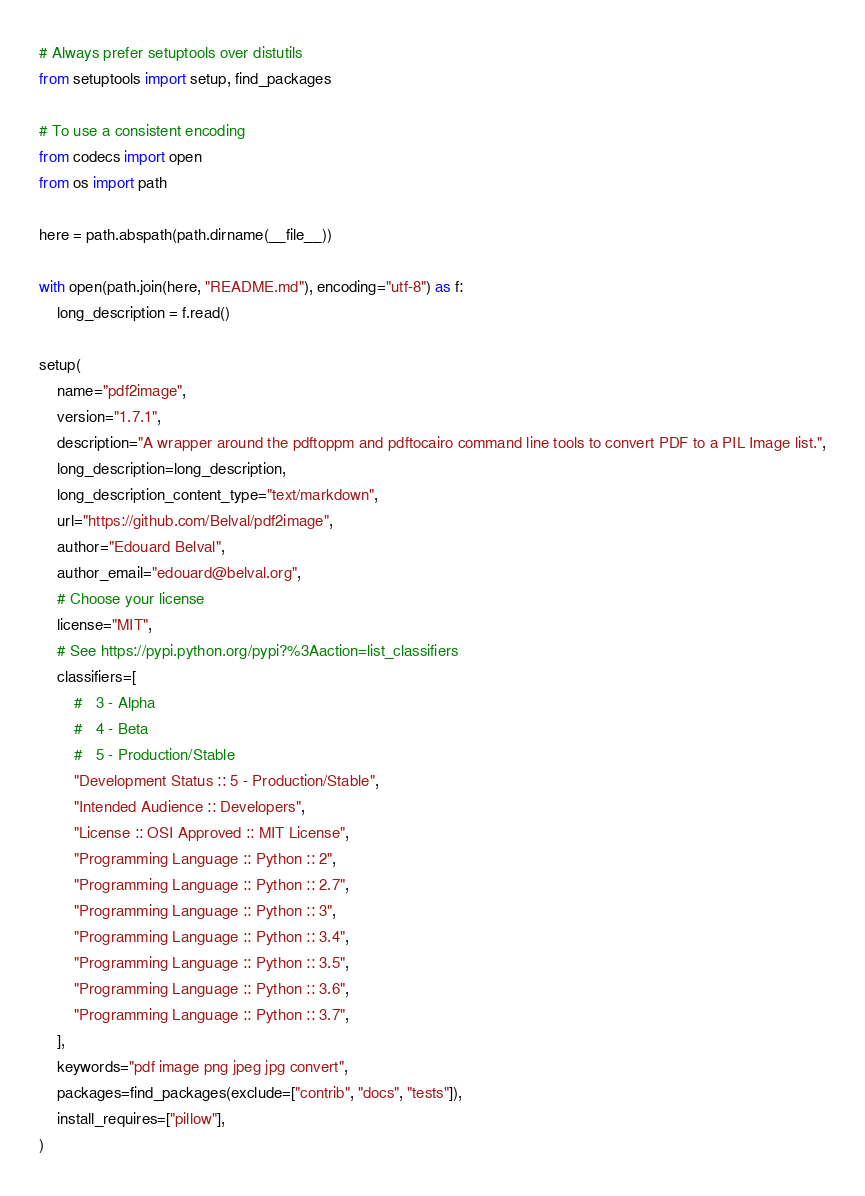Convert code to text. <code><loc_0><loc_0><loc_500><loc_500><_Python_># Always prefer setuptools over distutils
from setuptools import setup, find_packages

# To use a consistent encoding
from codecs import open
from os import path

here = path.abspath(path.dirname(__file__))

with open(path.join(here, "README.md"), encoding="utf-8") as f:
    long_description = f.read()

setup(
    name="pdf2image",
    version="1.7.1",
    description="A wrapper around the pdftoppm and pdftocairo command line tools to convert PDF to a PIL Image list.",
    long_description=long_description,
    long_description_content_type="text/markdown",
    url="https://github.com/Belval/pdf2image",
    author="Edouard Belval",
    author_email="edouard@belval.org",
    # Choose your license
    license="MIT",
    # See https://pypi.python.org/pypi?%3Aaction=list_classifiers
    classifiers=[
        #   3 - Alpha
        #   4 - Beta
        #   5 - Production/Stable
        "Development Status :: 5 - Production/Stable",
        "Intended Audience :: Developers",
        "License :: OSI Approved :: MIT License",
        "Programming Language :: Python :: 2",
        "Programming Language :: Python :: 2.7",
        "Programming Language :: Python :: 3",
        "Programming Language :: Python :: 3.4",
        "Programming Language :: Python :: 3.5",
        "Programming Language :: Python :: 3.6",
        "Programming Language :: Python :: 3.7",
    ],
    keywords="pdf image png jpeg jpg convert",
    packages=find_packages(exclude=["contrib", "docs", "tests"]),
    install_requires=["pillow"],
)
</code> 